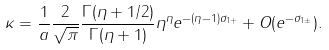Convert formula to latex. <formula><loc_0><loc_0><loc_500><loc_500>\kappa = \frac { 1 } { a } \frac { 2 } { \sqrt { \pi } } \frac { \Gamma ( \eta + 1 / 2 ) } { \Gamma ( \eta + 1 ) } \eta ^ { \eta } e ^ { - ( \eta - 1 ) \sigma _ { 1 + } } + O ( e ^ { - \sigma _ { 1 \pm } } ) .</formula> 